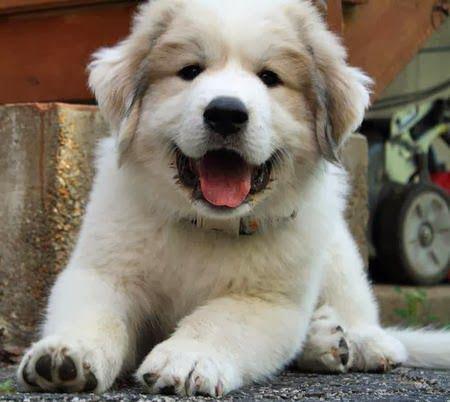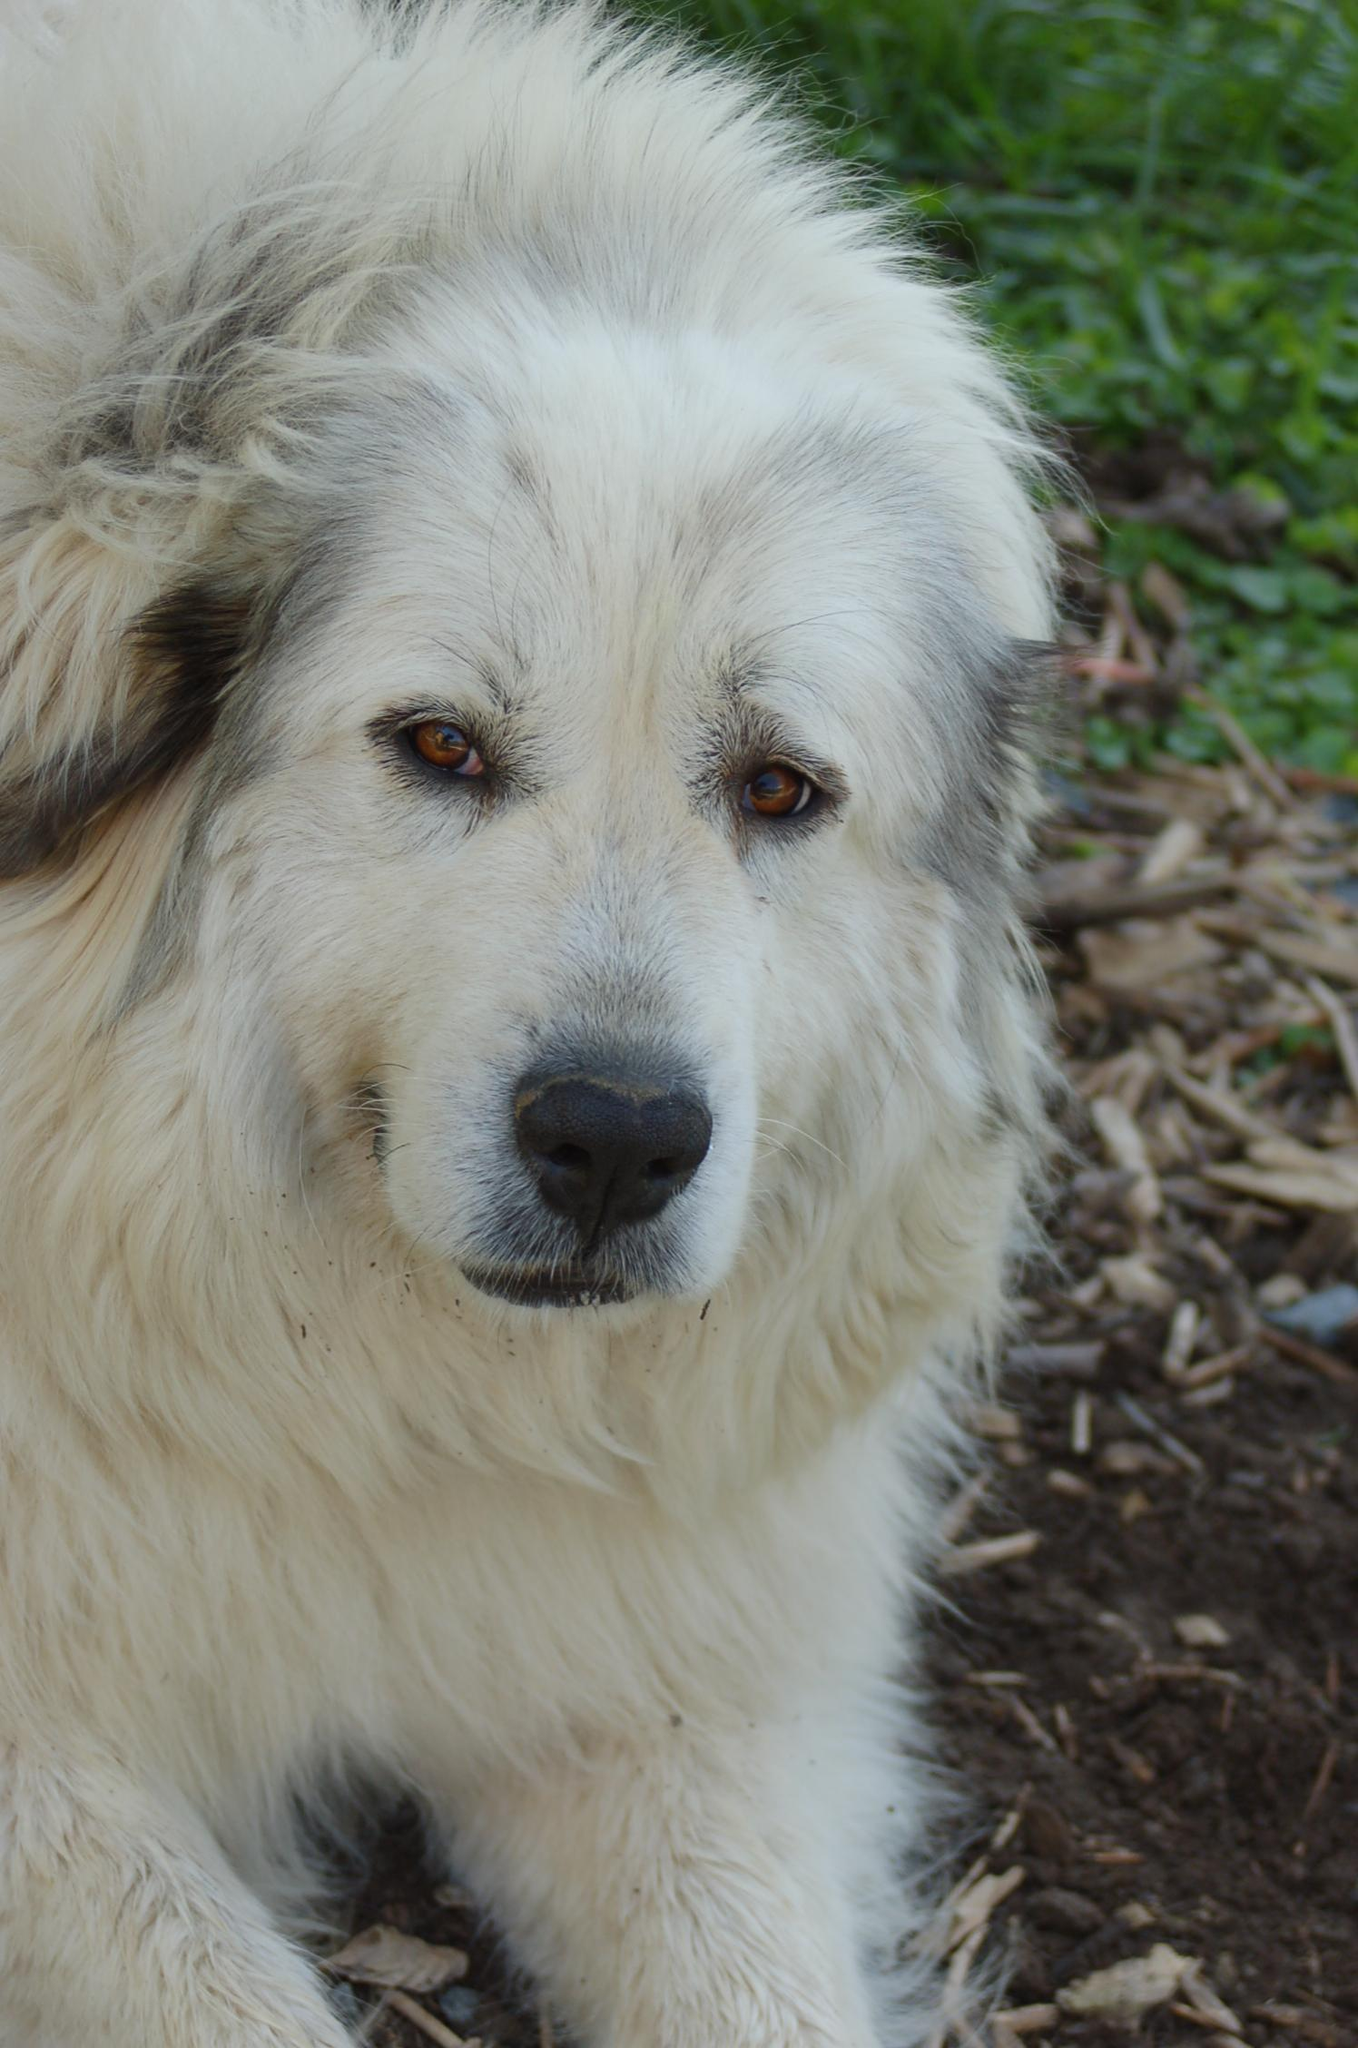The first image is the image on the left, the second image is the image on the right. Examine the images to the left and right. Is the description "The puppy on the left image is showing its tongue" accurate? Answer yes or no. Yes. 